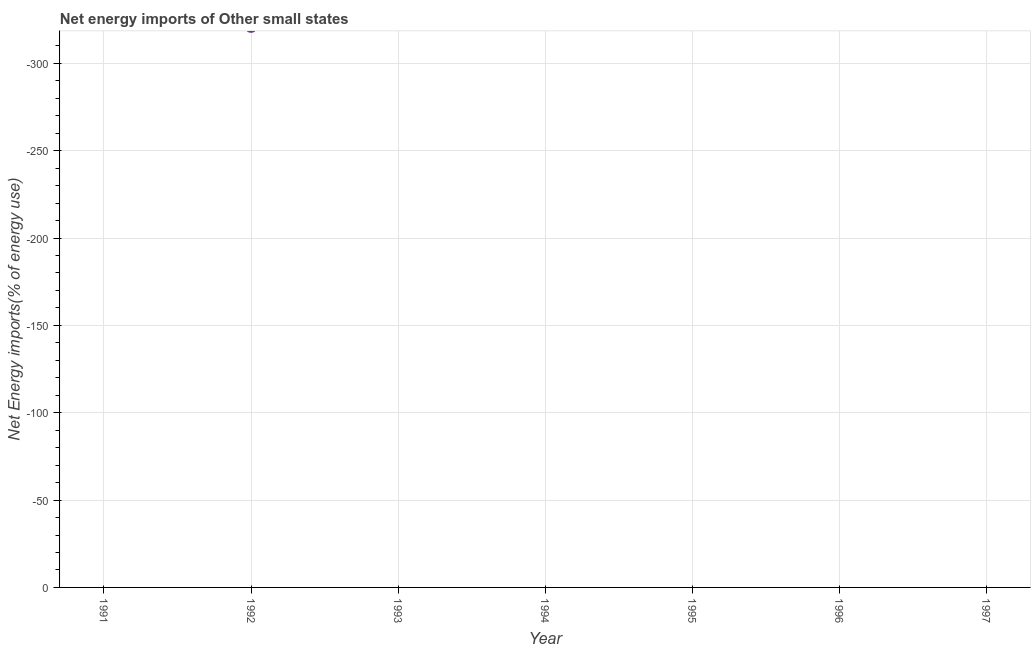What is the energy imports in 1994?
Give a very brief answer. 0. Across all years, what is the minimum energy imports?
Your response must be concise. 0. What is the sum of the energy imports?
Your response must be concise. 0. How many dotlines are there?
Give a very brief answer. 0. What is the difference between two consecutive major ticks on the Y-axis?
Offer a terse response. 50. Are the values on the major ticks of Y-axis written in scientific E-notation?
Provide a succinct answer. No. Does the graph contain any zero values?
Your answer should be very brief. Yes. What is the title of the graph?
Ensure brevity in your answer.  Net energy imports of Other small states. What is the label or title of the Y-axis?
Offer a terse response. Net Energy imports(% of energy use). What is the Net Energy imports(% of energy use) in 1994?
Keep it short and to the point. 0. What is the Net Energy imports(% of energy use) in 1996?
Ensure brevity in your answer.  0. 